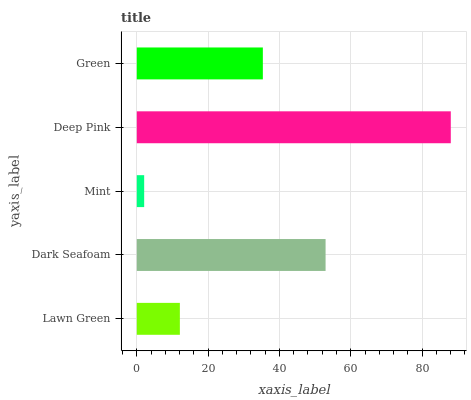Is Mint the minimum?
Answer yes or no. Yes. Is Deep Pink the maximum?
Answer yes or no. Yes. Is Dark Seafoam the minimum?
Answer yes or no. No. Is Dark Seafoam the maximum?
Answer yes or no. No. Is Dark Seafoam greater than Lawn Green?
Answer yes or no. Yes. Is Lawn Green less than Dark Seafoam?
Answer yes or no. Yes. Is Lawn Green greater than Dark Seafoam?
Answer yes or no. No. Is Dark Seafoam less than Lawn Green?
Answer yes or no. No. Is Green the high median?
Answer yes or no. Yes. Is Green the low median?
Answer yes or no. Yes. Is Mint the high median?
Answer yes or no. No. Is Dark Seafoam the low median?
Answer yes or no. No. 